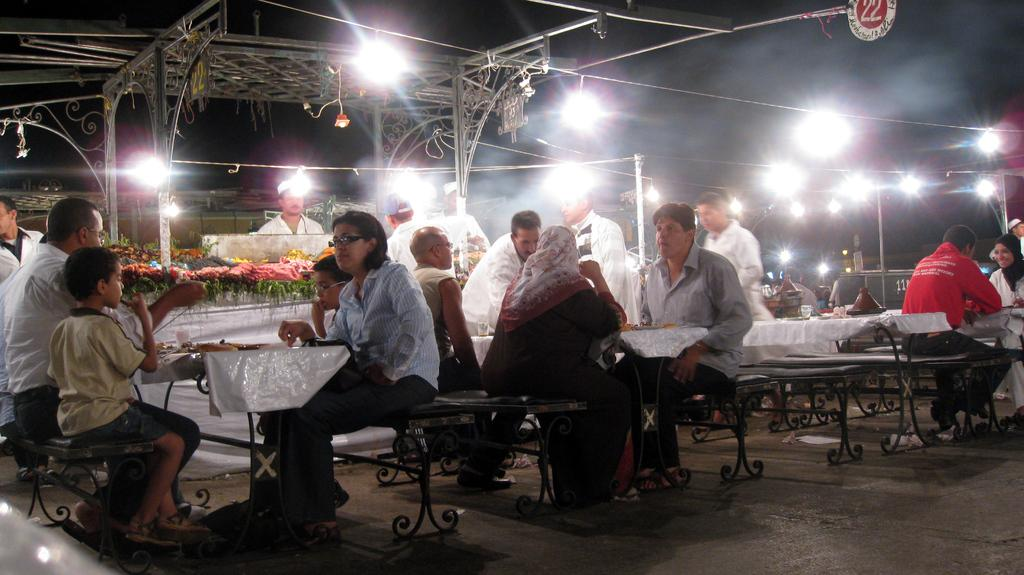How many people are in the image? There is a group of people in the image. What are the people doing in the image? The people are sitting in chairs. What is on the table in the image? There is a tissue and food items on the table. What can be seen in the background of the image? There are lights and flowers visible in the background. What type of creature is making noise with the bells in the image? There is no creature or bells present in the image. Where is the basket located in the image? There is no basket present in the image. 